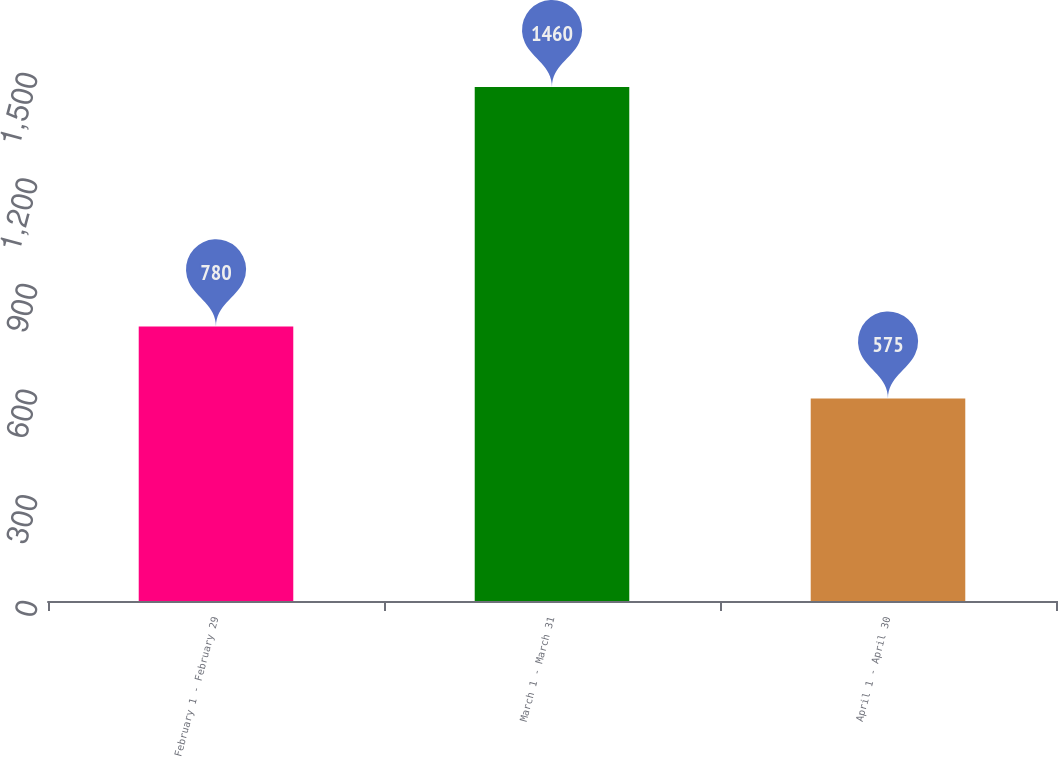Convert chart to OTSL. <chart><loc_0><loc_0><loc_500><loc_500><bar_chart><fcel>February 1 - February 29<fcel>March 1 - March 31<fcel>April 1 - April 30<nl><fcel>780<fcel>1460<fcel>575<nl></chart> 